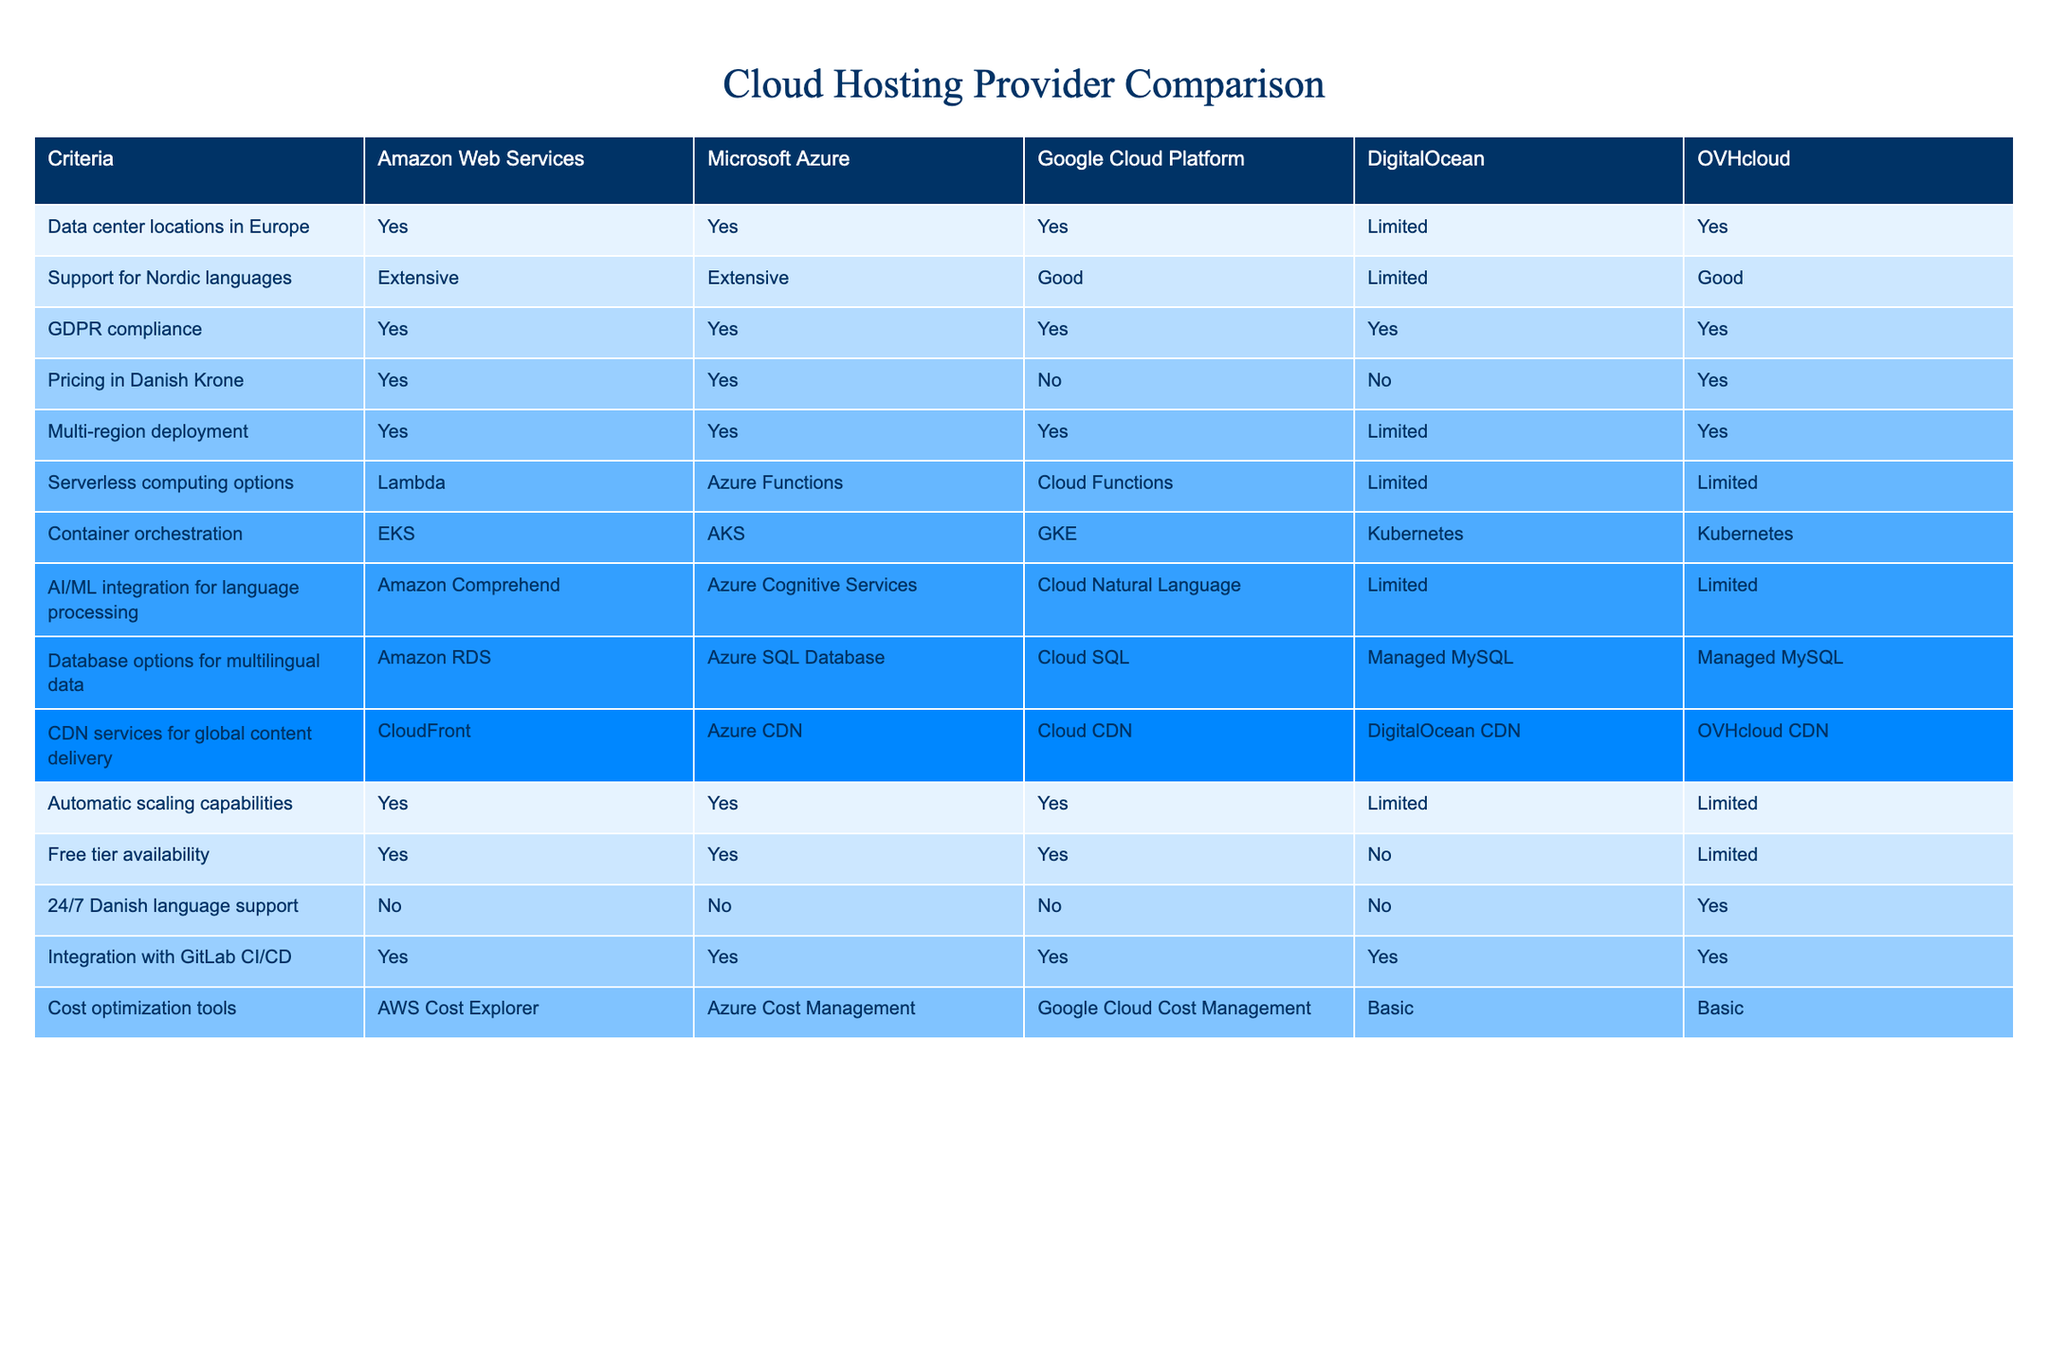What cloud hosting providers support GDPR compliance? By examining the table, we can see that all listed providers—Amazon Web Services, Microsoft Azure, Google Cloud Platform, DigitalOcean, and OVHcloud—indicate compliance with GDPR.
Answer: All providers Which provider offers serverless computing options? Looking at the entries under serverless computing options, we find that Amazon Web Services, Microsoft Azure, and Google Cloud Platform provide specific offerings (Lambda, Azure Functions, Cloud Functions), while DigitalOcean and OVHcloud have limited options.
Answer: Amazon Web Services, Microsoft Azure, Google Cloud Platform Does DigitalOcean offer 24/7 Danish language support? The table clearly states that DigitalOcean does not provide 24/7 support in Danish, as it indicates 'No' in that column.
Answer: No How many providers have extensive support for Nordic languages? The relevant column shows that both Amazon Web Services and Microsoft Azure have extensive support, while Google Cloud Platform offers good support and DigitalOcean has limited support. Thus, we count only the two providers with extensive support.
Answer: 2 Which providers allow pricing in Danish Krone? Reviewing the pricing information in Danish Krone, Amazon Web Services, Microsoft Azure, and OVHcloud provide this option as indicated by 'Yes,' while Google Cloud Platform and DigitalOcean do not, as indicated by 'No.'
Answer: Amazon Web Services, Microsoft Azure, OVHcloud If we consider only providers with multi-region deployment capabilities and extensive Nordic support, which ones qualify? First, we check for providers with multi-region deployment. Amazon Web Services, Microsoft Azure, and Google Cloud Platform all offer this. Then we check their support for Nordic languages: Amazon Web Services and Microsoft Azure have extensive support, thus narrowing it down to these two providers.
Answer: Amazon Web Services, Microsoft Azure What is the base cloud provider with the richest AI/ML integration for language processing? From the table, when analyzing AI/ML integration, Amazon Web Services offers Amazon Comprehend, which is the most developed option compared to others like Azure Cognitive Services or limited options from DigitalOcean and OVHcloud.
Answer: Amazon Web Services Which cloud provider has the best automatic scaling capabilities? Investigating the automatic scaling capabilities, we find that Amazon Web Services, Microsoft Azure, and Google Cloud Platform all have capabilities marked 'Yes,' indicating robust features, whereas DigitalOcean and OVHcloud have limited options.
Answer: Amazon Web Services, Microsoft Azure, Google Cloud Platform 